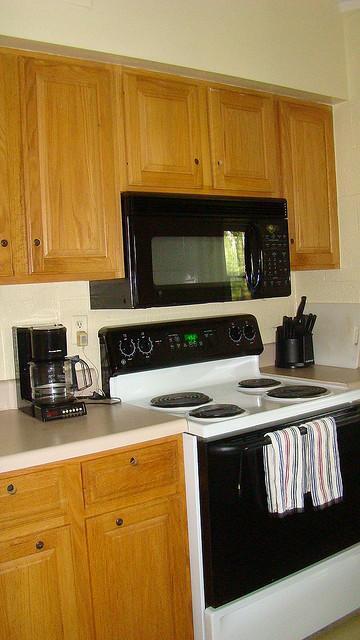How many pizzas are in the photo?
Give a very brief answer. 0. 